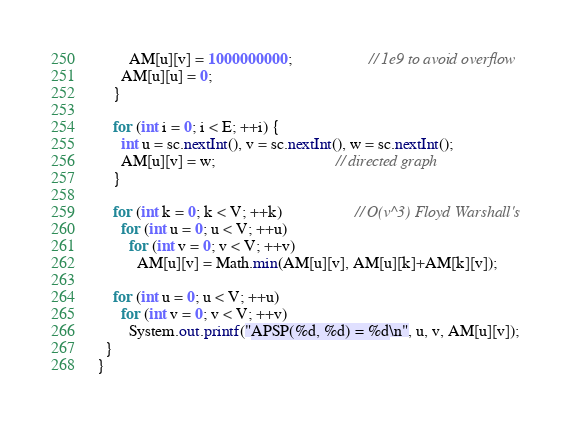Convert code to text. <code><loc_0><loc_0><loc_500><loc_500><_Java_>        AM[u][v] = 1000000000;                   // 1e9 to avoid overflow
      AM[u][u] = 0;
    }

    for (int i = 0; i < E; ++i) {
      int u = sc.nextInt(), v = sc.nextInt(), w = sc.nextInt();
      AM[u][v] = w;                              // directed graph
    }

    for (int k = 0; k < V; ++k)                  // O(v^3) Floyd Warshall's
      for (int u = 0; u < V; ++u)
        for (int v = 0; v < V; ++v)
          AM[u][v] = Math.min(AM[u][v], AM[u][k]+AM[k][v]);

    for (int u = 0; u < V; ++u)
      for (int v = 0; v < V; ++v)
        System.out.printf("APSP(%d, %d) = %d\n", u, v, AM[u][v]);
  }
}
</code> 